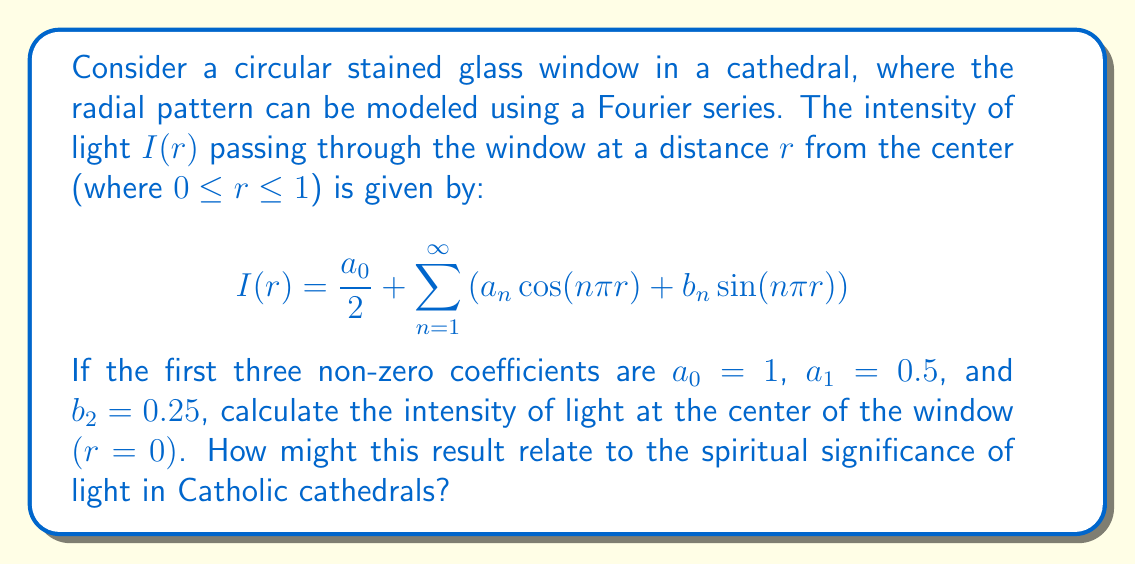Can you answer this question? To solve this problem, we need to evaluate the Fourier series at $r=0$. Let's break it down step-by-step:

1) The general form of the Fourier series is given by:
   $$I(r) = \frac{a_0}{2} + \sum_{n=1}^{\infty} \left(a_n \cos(n\pi r) + b_n \sin(n\pi r)\right)$$

2) We are given that $a_0 = 1$, $a_1 = 0.5$, and $b_2 = 0.25$. All other coefficients are zero.

3) At the center of the window, $r = 0$. Let's evaluate each term:

   - $\frac{a_0}{2} = \frac{1}{2} = 0.5$
   
   - $a_1 \cos(\pi r) = 0.5 \cos(0) = 0.5 \cdot 1 = 0.5$
   
   - $b_2 \sin(2\pi r) = 0.25 \sin(0) = 0.25 \cdot 0 = 0$

4) All other terms are zero, so we don't need to consider them.

5) Adding up the non-zero terms:
   $$I(0) = 0.5 + 0.5 + 0 = 1$$

From a spiritual perspective, this result shows that the light intensity is at its maximum (1) at the center of the window. In Catholic symbolism, light often represents the divine presence or God's grace. The fact that the light is most intense at the center could be interpreted as the central focus of faith or the idea that God is at the heart of all things.
Answer: The intensity of light at the center of the window is 1. 